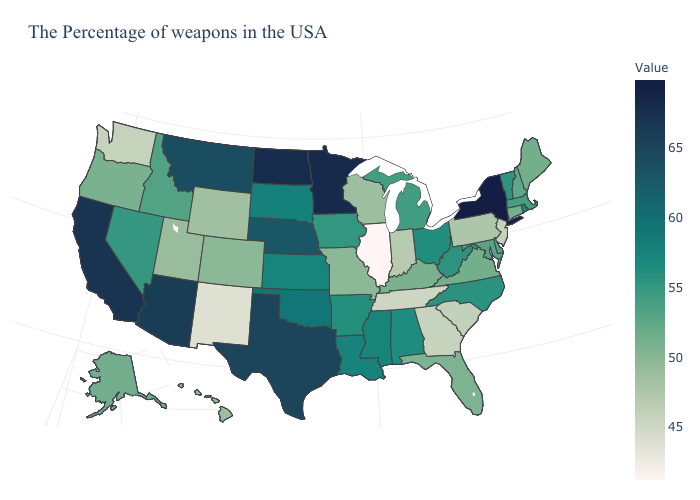Does Virginia have the lowest value in the USA?
Concise answer only. No. Among the states that border Montana , which have the highest value?
Write a very short answer. North Dakota. Which states have the highest value in the USA?
Concise answer only. New York. Among the states that border Mississippi , does Tennessee have the lowest value?
Concise answer only. Yes. Among the states that border South Carolina , which have the highest value?
Give a very brief answer. North Carolina. 